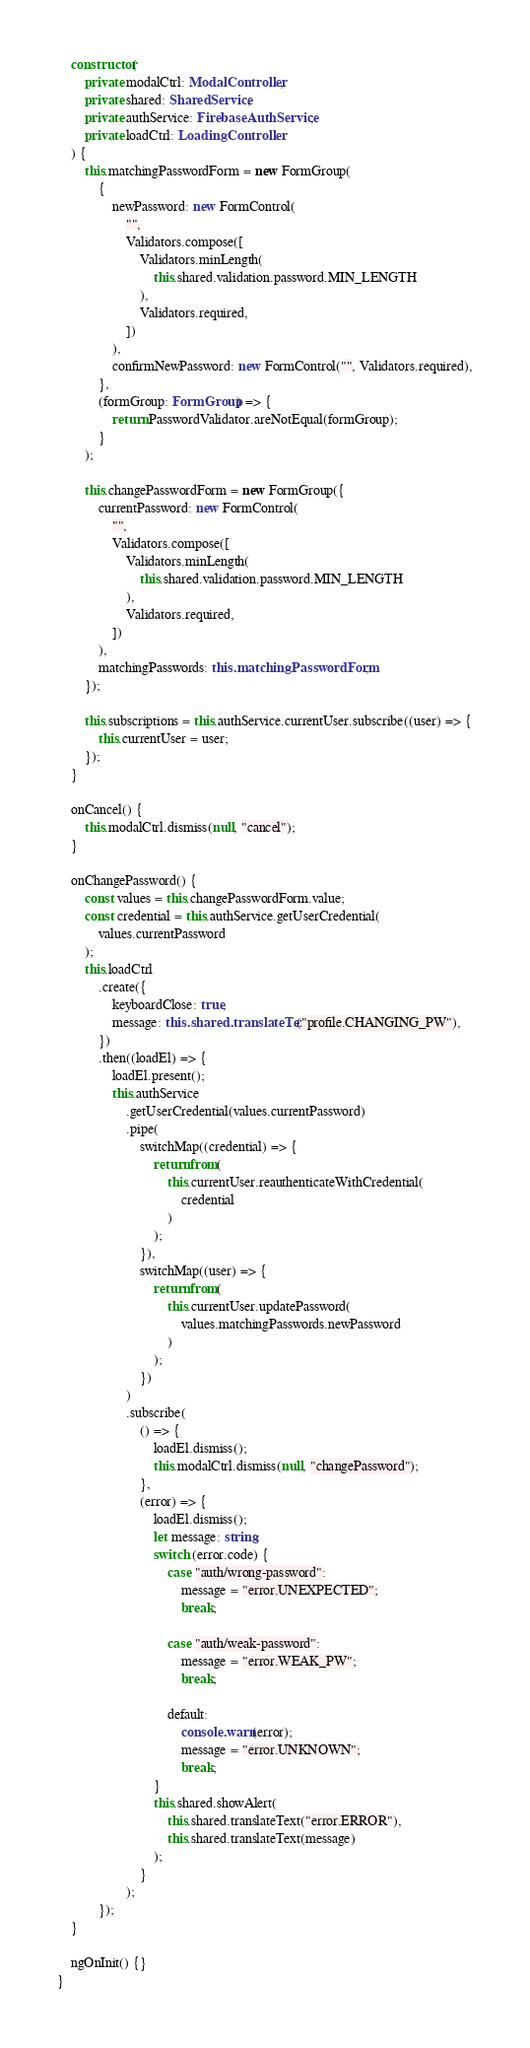<code> <loc_0><loc_0><loc_500><loc_500><_TypeScript_>	constructor(
		private modalCtrl: ModalController,
		private shared: SharedService,
		private authService: FirebaseAuthService,
		private loadCtrl: LoadingController
	) {
		this.matchingPasswordForm = new FormGroup(
			{
				newPassword: new FormControl(
					"",
					Validators.compose([
						Validators.minLength(
							this.shared.validation.password.MIN_LENGTH
						),
						Validators.required,
					])
				),
				confirmNewPassword: new FormControl("", Validators.required),
			},
			(formGroup: FormGroup) => {
				return PasswordValidator.areNotEqual(formGroup);
			}
		);

		this.changePasswordForm = new FormGroup({
			currentPassword: new FormControl(
				"",
				Validators.compose([
					Validators.minLength(
						this.shared.validation.password.MIN_LENGTH
					),
					Validators.required,
				])
			),
			matchingPasswords: this.matchingPasswordForm,
		});

		this.subscriptions = this.authService.currentUser.subscribe((user) => {
			this.currentUser = user;
		});
	}

	onCancel() {
		this.modalCtrl.dismiss(null, "cancel");
	}

	onChangePassword() {
		const values = this.changePasswordForm.value;
		const credential = this.authService.getUserCredential(
			values.currentPassword
		);
		this.loadCtrl
			.create({
				keyboardClose: true,
				message: this.shared.translateText("profile.CHANGING_PW"),
			})
			.then((loadEl) => {
				loadEl.present();
				this.authService
					.getUserCredential(values.currentPassword)
					.pipe(
						switchMap((credential) => {
							return from(
								this.currentUser.reauthenticateWithCredential(
									credential
								)
							);
						}),
						switchMap((user) => {
							return from(
								this.currentUser.updatePassword(
									values.matchingPasswords.newPassword
								)
							);
						})
					)
					.subscribe(
						() => {
							loadEl.dismiss();
							this.modalCtrl.dismiss(null, "changePassword");
						},
						(error) => {
							loadEl.dismiss();
							let message: string;
							switch (error.code) {
								case "auth/wrong-password":
									message = "error.UNEXPECTED";
									break;

								case "auth/weak-password":
									message = "error.WEAK_PW";
									break;

								default:
									console.warn(error);
									message = "error.UNKNOWN";
									break;
							}
							this.shared.showAlert(
								this.shared.translateText("error.ERROR"),
								this.shared.translateText(message)
							);
						}
					);
			});
	}

	ngOnInit() {}
}
</code> 